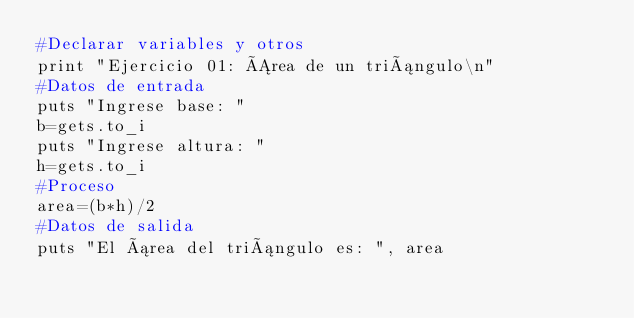Convert code to text. <code><loc_0><loc_0><loc_500><loc_500><_Ruby_>#Declarar variables y otros
print "Ejercicio 01: Área de un triángulo\n"
#Datos de entrada
puts "Ingrese base: "
b=gets.to_i
puts "Ingrese altura: "
h=gets.to_i
#Proceso
area=(b*h)/2
#Datos de salida
puts "El área del triángulo es: ", area</code> 